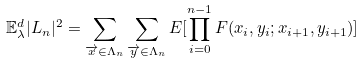<formula> <loc_0><loc_0><loc_500><loc_500>\mathbb { E } _ { \lambda } ^ { d } | L _ { n } | ^ { 2 } & = \sum _ { \overrightarrow { x } \in \Lambda _ { n } } \sum _ { \overrightarrow { y } \in \Lambda _ { n } } E [ \prod _ { i = 0 } ^ { n - 1 } F ( x _ { i } , y _ { i } ; x _ { i + 1 } , y _ { i + 1 } ) ]</formula> 